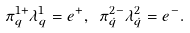<formula> <loc_0><loc_0><loc_500><loc_500>\pi _ { q } ^ { 1 + } \lambda _ { q } ^ { 1 } = e ^ { + } , \ \pi _ { \dot { q } } ^ { 2 - } \lambda _ { \dot { q } } ^ { 2 } = e ^ { - } .</formula> 